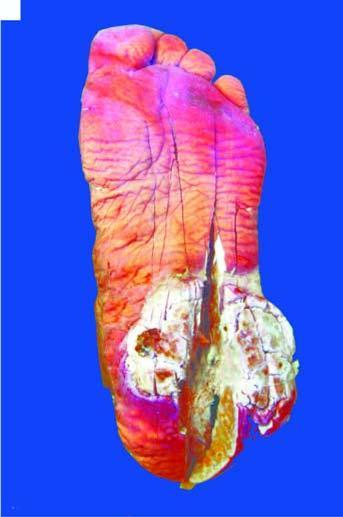does equipments show a fungating and ulcerated growth?
Answer the question using a single word or phrase. No 